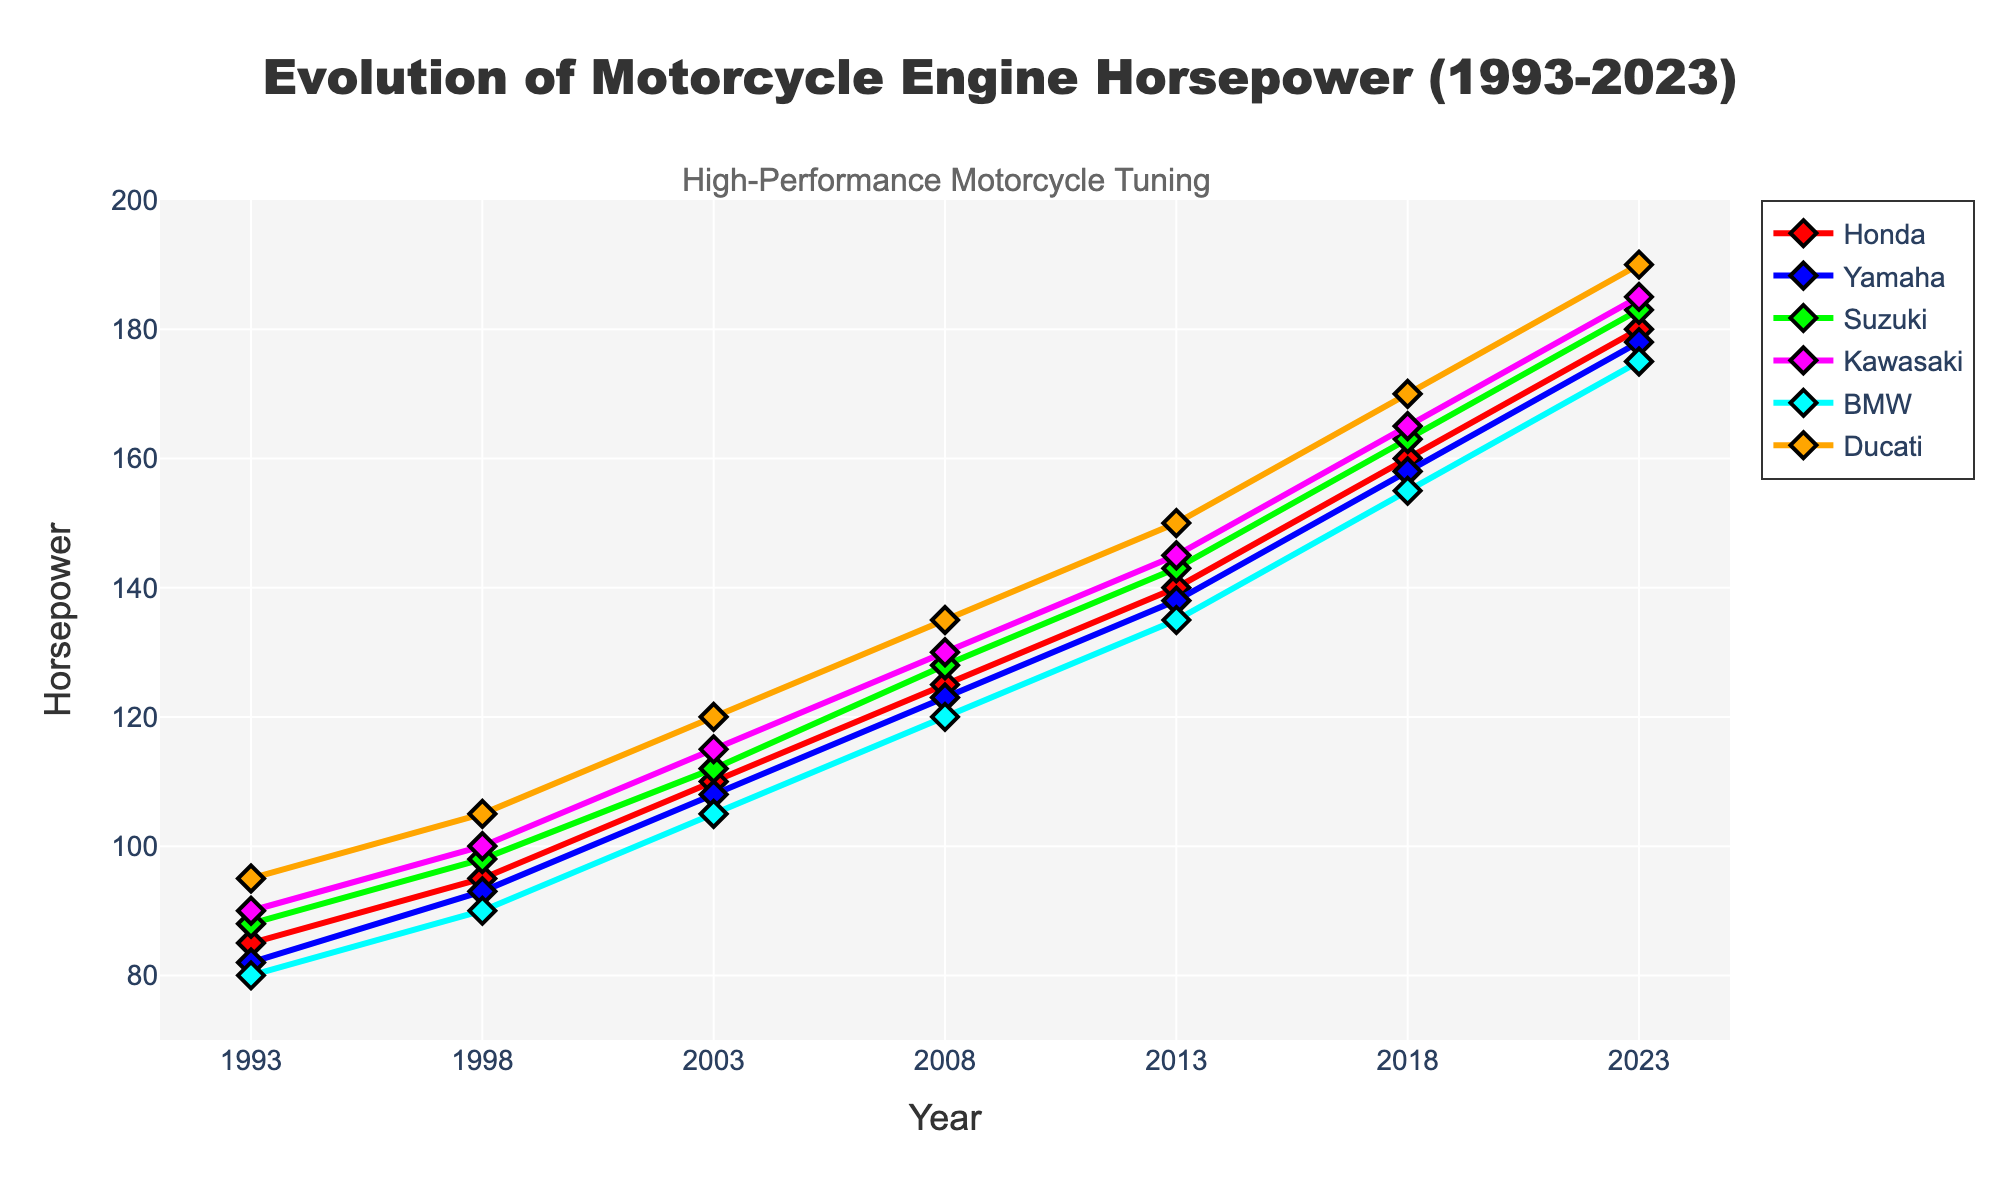How has Honda's horsepower evolved from 1993 to 2023? Honda's horsepower increased over the years from 85 in 1993 to 180 in 2023. The data shows a consistent rise every 5 years.
Answer: 85 to 180 Which manufacturer had the highest horsepower in 2023? By observing the top values for each line in 2023, Ducati had the highest horsepower at 190.
Answer: Ducati In what year did BMW reach a horsepower of 120? Track the BMW line and find the year corresponding to the 120 horsepower value, which is in 2008.
Answer: 2008 Between 1998 and 2003, which manufacturer showed the greatest increase in horsepower? Subtract the 1998 values from the 2003 values for each manufacturer: Honda (15), Yamaha (15), Suzuki (14), Kawasaki (15), BMW (15), Ducati (15). Ducati, alongside others, shows the greatest increase of 15.
Answer: Ducati What is the average horsepower across all manufacturers in 2018? Sum the 2018 horsepower values (160, 158, 163, 165, 155, 170) and divide by 6: (160+158+163+165+155+170)/6 = 971/6 = 161.83.
Answer: 161.83 When did Kawasaki overtook Yamaha in horsepower? By comparing the lines, you see Kawasaki surpassed Yamaha between 2013 and 2018.
Answer: Between 2013 and 2018 From 1993 to 2023, which manufacturer displayed the most consistent growth in horsepower? Visually inspecting the slopes of the lines, Kawasaki shows a consistently steeper line indicating steady growth.
Answer: Kawasaki How many years did Ducati lead in horsepower among all manufacturers? Ducati leads from 1993 to 2023 as their horsepower value is the highest over the entire period.
Answer: 30 years What is the difference in horsepower between Suzuki and BMW in 2003? In 2003, Suzuki’s horsepower is 112 and BMW's is 105. The difference is 112 - 105 = 7.
Answer: 7 Which manufacturer had the least horsepower gain from 1993 to 2023? Calculate the difference from 2023 to 1993 for each manufacturer. BMW had an increase from 80 to 175, an increase of 95 which is less compared to others.
Answer: BMW 